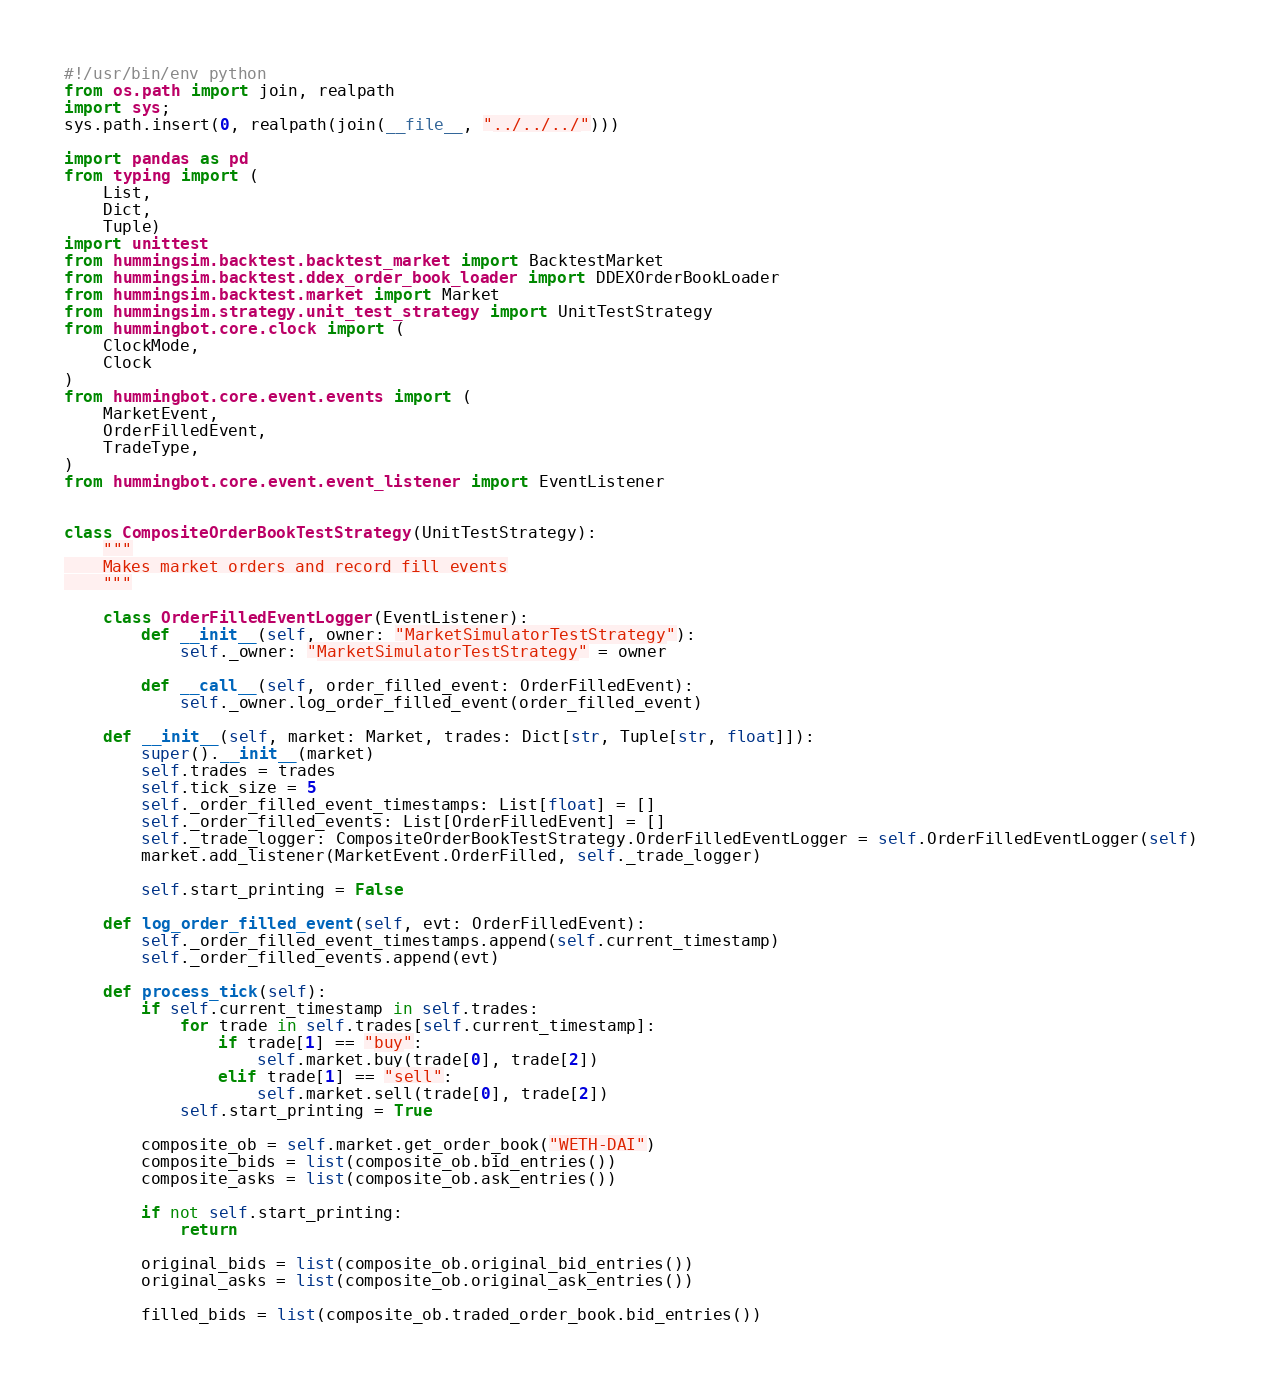Convert code to text. <code><loc_0><loc_0><loc_500><loc_500><_Python_>#!/usr/bin/env python
from os.path import join, realpath
import sys;
sys.path.insert(0, realpath(join(__file__, "../../../")))

import pandas as pd
from typing import (
    List,
    Dict,
    Tuple)
import unittest
from hummingsim.backtest.backtest_market import BacktestMarket
from hummingsim.backtest.ddex_order_book_loader import DDEXOrderBookLoader
from hummingsim.backtest.market import Market
from hummingsim.strategy.unit_test_strategy import UnitTestStrategy
from hummingbot.core.clock import (
    ClockMode,
    Clock
)
from hummingbot.core.event.events import (
    MarketEvent,
    OrderFilledEvent,
    TradeType,
)
from hummingbot.core.event.event_listener import EventListener


class CompositeOrderBookTestStrategy(UnitTestStrategy):
    """
    Makes market orders and record fill events
    """

    class OrderFilledEventLogger(EventListener):
        def __init__(self, owner: "MarketSimulatorTestStrategy"):
            self._owner: "MarketSimulatorTestStrategy" = owner

        def __call__(self, order_filled_event: OrderFilledEvent):
            self._owner.log_order_filled_event(order_filled_event)

    def __init__(self, market: Market, trades: Dict[str, Tuple[str, float]]):
        super().__init__(market)
        self.trades = trades
        self.tick_size = 5
        self._order_filled_event_timestamps: List[float] = []
        self._order_filled_events: List[OrderFilledEvent] = []
        self._trade_logger: CompositeOrderBookTestStrategy.OrderFilledEventLogger = self.OrderFilledEventLogger(self)
        market.add_listener(MarketEvent.OrderFilled, self._trade_logger)

        self.start_printing = False

    def log_order_filled_event(self, evt: OrderFilledEvent):
        self._order_filled_event_timestamps.append(self.current_timestamp)
        self._order_filled_events.append(evt)

    def process_tick(self):
        if self.current_timestamp in self.trades:
            for trade in self.trades[self.current_timestamp]:
                if trade[1] == "buy":
                    self.market.buy(trade[0], trade[2])
                elif trade[1] == "sell":
                    self.market.sell(trade[0], trade[2])
            self.start_printing = True

        composite_ob = self.market.get_order_book("WETH-DAI")
        composite_bids = list(composite_ob.bid_entries())
        composite_asks = list(composite_ob.ask_entries())

        if not self.start_printing:
            return

        original_bids = list(composite_ob.original_bid_entries())
        original_asks = list(composite_ob.original_ask_entries())

        filled_bids = list(composite_ob.traded_order_book.bid_entries())</code> 